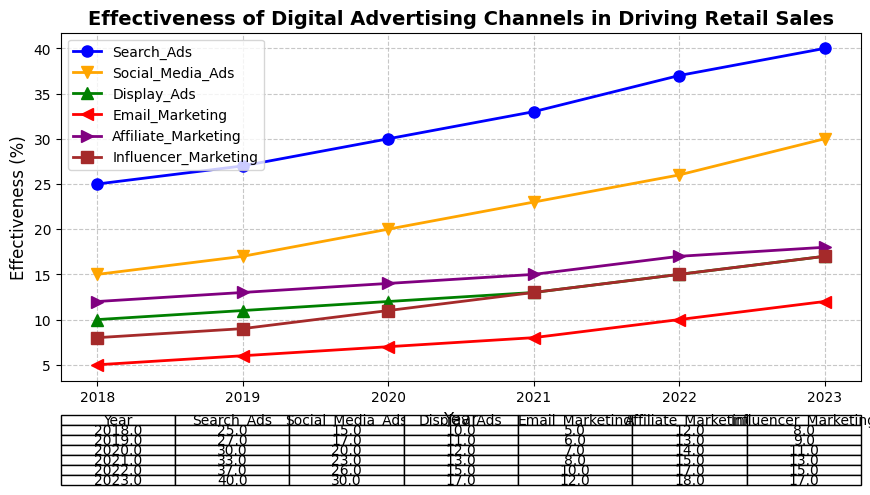Which digital advertising channel had the highest effectiveness in driving retail sales in 2023? To find the answer, check the plotted lines for the year 2023 and identify which one reaches the highest percentage. Search Ads reach 40.0%, higher than any other channel.
Answer: Search Ads Between 2019 and 2022, how much did the effectiveness of Social Media Ads increase? Subtract the effectiveness percentage of Social Media Ads in 2019 (17.0%) from its effectiveness in 2022 (26.0%) to find the increase. 26.0% - 17.0% = 9.0%.
Answer: 9.0% In which year did Display Ads and Email Marketing have the same effectiveness? Compare the effectiveness percentages for Display Ads and Email Marketing year by year. In 2020, both Display Ads and Email Marketing have the same effectiveness of 12.0%.
Answer: 2020 Which digital advertising channels showed continuous growth in effectiveness from 2018 to 2023 without any drop? Examine each advertising channel’s trend over the years. Both Search Ads and Social Media Ads show a continuous increase in effectiveness from 2018 to 2023 without any decline.
Answer: Search Ads, Social Media Ads What was the average effectiveness of Influencer Marketing over all years? Sum the effectiveness percentages of Influencer Marketing from 2018 to 2023 and divide by the number of years: (8.0 + 9.0 + 11.0 + 13.0 + 15.0 + 17.0) / 6 = 12.167%.
Answer: 12.167% Which year saw the largest year-over-year increase in effectiveness for Affiliate Marketing? Calculate the yearly increases for Affiliate Marketing and compare them. The largest increase occurred between 2021 (15.0%) and 2022 (17.0%), which is 2.0%.
Answer: 2022 How does the effectiveness of Email Marketing in 2023 compare to the effectiveness of Social Media Ads in 2018? Check the plotted values: Email Marketing has an effectiveness of 12.0% in 2023 and Social Media Ads had 15.0% in 2018. Compare the two values.
Answer: Social Media Ads in 2018 is higher What is the total effectiveness of all advertising channels combined in 2021? Sum the effectiveness percentages of all advertising channels for 2021: 33.0% (Search Ads) + 23.0% (Social Media Ads) + 13.0% (Display Ads) + 8.0% (Email Marketing) + 15.0% (Affiliate Marketing) + 13.0% (Influencer Marketing) = 105.0%.
Answer: 105.0% Which advertising channel had the smallest increase in effectiveness from 2018 to 2019? Calculate the increase for each channel: Search Ads (2.0%), Social Media Ads (2.0%), Display Ads (1.0%), Email Marketing (1.0%), Affiliate Marketing (1.0%), Influencer Marketing (1.0%), then compare.
Answer: Display Ads, Email Marketing, Affiliate Marketing, Influencer Marketing (all 1.0%) In which year did Affiliate Marketing reach an effectiveness of 14.0%? Check the effectiveness percentages of Affiliate Marketing for each year. Affiliate Marketing had an effectiveness of 14.0% in 2020.
Answer: 2020 